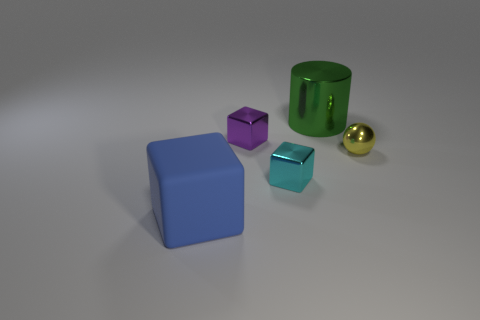Is there another cyan matte cube of the same size as the matte block?
Your answer should be compact. No. What number of metal objects are either tiny yellow cubes or things?
Offer a very short reply. 4. How many small purple metallic things are there?
Your answer should be very brief. 1. Do the large object right of the blue rubber cube and the thing left of the small purple block have the same material?
Provide a short and direct response. No. There is a green cylinder that is made of the same material as the yellow sphere; what is its size?
Provide a succinct answer. Large. There is a big blue matte thing in front of the tiny yellow thing; what is its shape?
Offer a terse response. Cube. Does the metal block behind the tiny yellow ball have the same color as the large thing in front of the yellow shiny thing?
Give a very brief answer. No. Is there a brown matte cube?
Ensure brevity in your answer.  No. There is a big thing that is behind the big rubber thing that is in front of the green cylinder that is right of the cyan metallic cube; what shape is it?
Ensure brevity in your answer.  Cylinder. There is a large green cylinder; what number of rubber cubes are on the right side of it?
Provide a short and direct response. 0. 